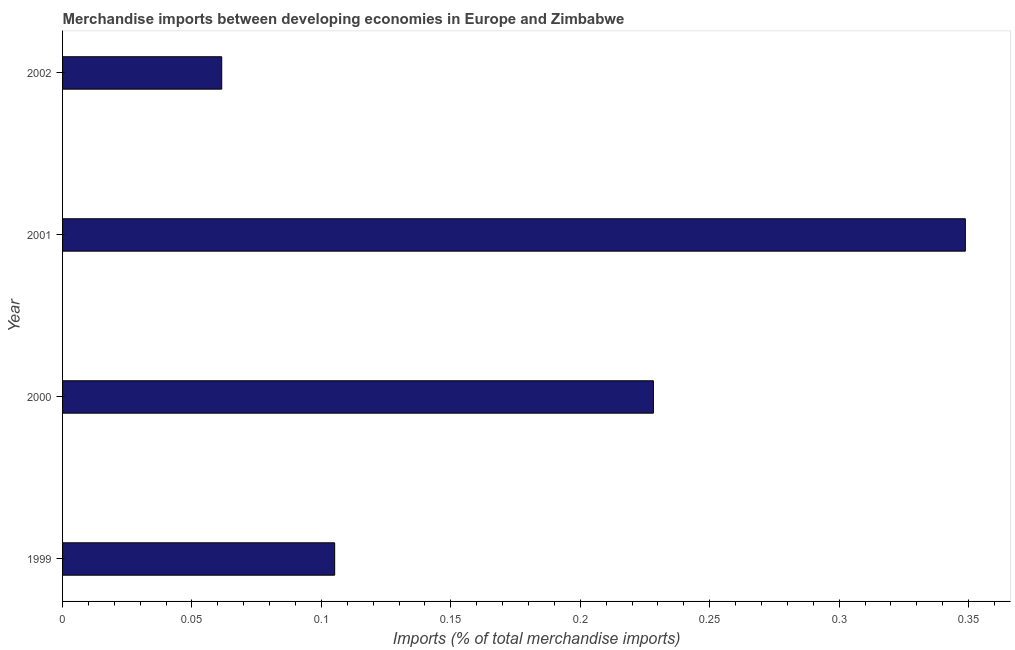Does the graph contain grids?
Give a very brief answer. No. What is the title of the graph?
Provide a succinct answer. Merchandise imports between developing economies in Europe and Zimbabwe. What is the label or title of the X-axis?
Offer a very short reply. Imports (% of total merchandise imports). What is the merchandise imports in 2001?
Offer a very short reply. 0.35. Across all years, what is the maximum merchandise imports?
Your response must be concise. 0.35. Across all years, what is the minimum merchandise imports?
Your response must be concise. 0.06. In which year was the merchandise imports minimum?
Your answer should be very brief. 2002. What is the sum of the merchandise imports?
Ensure brevity in your answer.  0.74. What is the difference between the merchandise imports in 1999 and 2000?
Ensure brevity in your answer.  -0.12. What is the average merchandise imports per year?
Your answer should be very brief. 0.19. What is the median merchandise imports?
Make the answer very short. 0.17. Do a majority of the years between 2000 and 2001 (inclusive) have merchandise imports greater than 0.17 %?
Give a very brief answer. Yes. What is the ratio of the merchandise imports in 1999 to that in 2001?
Your answer should be compact. 0.3. Is the merchandise imports in 2000 less than that in 2002?
Keep it short and to the point. No. Is the difference between the merchandise imports in 1999 and 2000 greater than the difference between any two years?
Ensure brevity in your answer.  No. What is the difference between the highest and the second highest merchandise imports?
Make the answer very short. 0.12. What is the difference between the highest and the lowest merchandise imports?
Keep it short and to the point. 0.29. In how many years, is the merchandise imports greater than the average merchandise imports taken over all years?
Give a very brief answer. 2. How many bars are there?
Your answer should be compact. 4. Are all the bars in the graph horizontal?
Your answer should be very brief. Yes. What is the difference between two consecutive major ticks on the X-axis?
Keep it short and to the point. 0.05. Are the values on the major ticks of X-axis written in scientific E-notation?
Your answer should be very brief. No. What is the Imports (% of total merchandise imports) in 1999?
Ensure brevity in your answer.  0.11. What is the Imports (% of total merchandise imports) in 2000?
Provide a short and direct response. 0.23. What is the Imports (% of total merchandise imports) of 2001?
Make the answer very short. 0.35. What is the Imports (% of total merchandise imports) in 2002?
Your response must be concise. 0.06. What is the difference between the Imports (% of total merchandise imports) in 1999 and 2000?
Your answer should be very brief. -0.12. What is the difference between the Imports (% of total merchandise imports) in 1999 and 2001?
Offer a very short reply. -0.24. What is the difference between the Imports (% of total merchandise imports) in 1999 and 2002?
Keep it short and to the point. 0.04. What is the difference between the Imports (% of total merchandise imports) in 2000 and 2001?
Your response must be concise. -0.12. What is the difference between the Imports (% of total merchandise imports) in 2000 and 2002?
Make the answer very short. 0.17. What is the difference between the Imports (% of total merchandise imports) in 2001 and 2002?
Offer a very short reply. 0.29. What is the ratio of the Imports (% of total merchandise imports) in 1999 to that in 2000?
Your answer should be compact. 0.46. What is the ratio of the Imports (% of total merchandise imports) in 1999 to that in 2001?
Your response must be concise. 0.3. What is the ratio of the Imports (% of total merchandise imports) in 1999 to that in 2002?
Your answer should be very brief. 1.71. What is the ratio of the Imports (% of total merchandise imports) in 2000 to that in 2001?
Offer a terse response. 0.65. What is the ratio of the Imports (% of total merchandise imports) in 2000 to that in 2002?
Ensure brevity in your answer.  3.71. What is the ratio of the Imports (% of total merchandise imports) in 2001 to that in 2002?
Your answer should be compact. 5.67. 